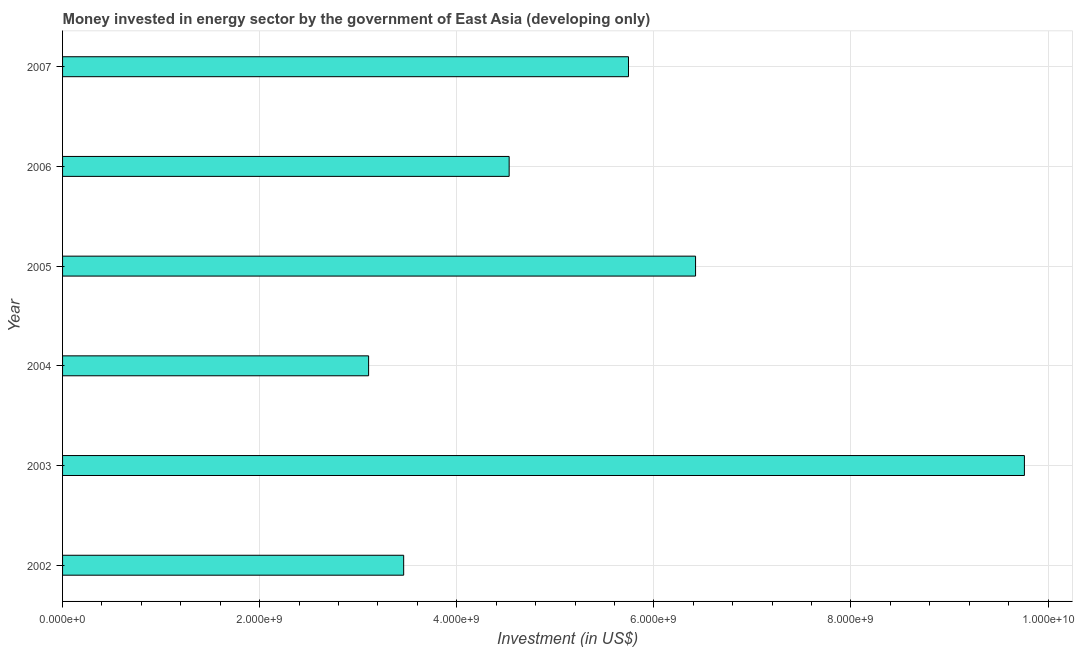Does the graph contain any zero values?
Offer a very short reply. No. Does the graph contain grids?
Give a very brief answer. Yes. What is the title of the graph?
Provide a short and direct response. Money invested in energy sector by the government of East Asia (developing only). What is the label or title of the X-axis?
Provide a succinct answer. Investment (in US$). What is the investment in energy in 2004?
Your answer should be compact. 3.11e+09. Across all years, what is the maximum investment in energy?
Make the answer very short. 9.76e+09. Across all years, what is the minimum investment in energy?
Offer a terse response. 3.11e+09. In which year was the investment in energy minimum?
Provide a short and direct response. 2004. What is the sum of the investment in energy?
Give a very brief answer. 3.30e+1. What is the difference between the investment in energy in 2006 and 2007?
Ensure brevity in your answer.  -1.21e+09. What is the average investment in energy per year?
Offer a terse response. 5.50e+09. What is the median investment in energy?
Make the answer very short. 5.14e+09. In how many years, is the investment in energy greater than 4800000000 US$?
Offer a terse response. 3. What is the ratio of the investment in energy in 2003 to that in 2007?
Provide a succinct answer. 1.7. Is the difference between the investment in energy in 2005 and 2006 greater than the difference between any two years?
Give a very brief answer. No. What is the difference between the highest and the second highest investment in energy?
Keep it short and to the point. 3.34e+09. What is the difference between the highest and the lowest investment in energy?
Your answer should be very brief. 6.65e+09. In how many years, is the investment in energy greater than the average investment in energy taken over all years?
Give a very brief answer. 3. How many bars are there?
Your answer should be very brief. 6. Are all the bars in the graph horizontal?
Make the answer very short. Yes. Are the values on the major ticks of X-axis written in scientific E-notation?
Give a very brief answer. Yes. What is the Investment (in US$) in 2002?
Provide a succinct answer. 3.46e+09. What is the Investment (in US$) of 2003?
Make the answer very short. 9.76e+09. What is the Investment (in US$) in 2004?
Your answer should be compact. 3.11e+09. What is the Investment (in US$) of 2005?
Keep it short and to the point. 6.42e+09. What is the Investment (in US$) of 2006?
Keep it short and to the point. 4.53e+09. What is the Investment (in US$) in 2007?
Provide a short and direct response. 5.74e+09. What is the difference between the Investment (in US$) in 2002 and 2003?
Make the answer very short. -6.30e+09. What is the difference between the Investment (in US$) in 2002 and 2004?
Offer a very short reply. 3.56e+08. What is the difference between the Investment (in US$) in 2002 and 2005?
Your response must be concise. -2.96e+09. What is the difference between the Investment (in US$) in 2002 and 2006?
Your answer should be very brief. -1.07e+09. What is the difference between the Investment (in US$) in 2002 and 2007?
Your answer should be very brief. -2.28e+09. What is the difference between the Investment (in US$) in 2003 and 2004?
Offer a terse response. 6.65e+09. What is the difference between the Investment (in US$) in 2003 and 2005?
Ensure brevity in your answer.  3.34e+09. What is the difference between the Investment (in US$) in 2003 and 2006?
Provide a succinct answer. 5.23e+09. What is the difference between the Investment (in US$) in 2003 and 2007?
Provide a short and direct response. 4.02e+09. What is the difference between the Investment (in US$) in 2004 and 2005?
Ensure brevity in your answer.  -3.32e+09. What is the difference between the Investment (in US$) in 2004 and 2006?
Your answer should be compact. -1.43e+09. What is the difference between the Investment (in US$) in 2004 and 2007?
Your response must be concise. -2.64e+09. What is the difference between the Investment (in US$) in 2005 and 2006?
Provide a succinct answer. 1.89e+09. What is the difference between the Investment (in US$) in 2005 and 2007?
Your response must be concise. 6.81e+08. What is the difference between the Investment (in US$) in 2006 and 2007?
Your answer should be compact. -1.21e+09. What is the ratio of the Investment (in US$) in 2002 to that in 2003?
Offer a very short reply. 0.35. What is the ratio of the Investment (in US$) in 2002 to that in 2004?
Ensure brevity in your answer.  1.11. What is the ratio of the Investment (in US$) in 2002 to that in 2005?
Keep it short and to the point. 0.54. What is the ratio of the Investment (in US$) in 2002 to that in 2006?
Keep it short and to the point. 0.76. What is the ratio of the Investment (in US$) in 2002 to that in 2007?
Make the answer very short. 0.6. What is the ratio of the Investment (in US$) in 2003 to that in 2004?
Offer a very short reply. 3.14. What is the ratio of the Investment (in US$) in 2003 to that in 2005?
Make the answer very short. 1.52. What is the ratio of the Investment (in US$) in 2003 to that in 2006?
Your answer should be very brief. 2.15. What is the ratio of the Investment (in US$) in 2004 to that in 2005?
Your answer should be compact. 0.48. What is the ratio of the Investment (in US$) in 2004 to that in 2006?
Ensure brevity in your answer.  0.69. What is the ratio of the Investment (in US$) in 2004 to that in 2007?
Offer a very short reply. 0.54. What is the ratio of the Investment (in US$) in 2005 to that in 2006?
Make the answer very short. 1.42. What is the ratio of the Investment (in US$) in 2005 to that in 2007?
Provide a short and direct response. 1.12. What is the ratio of the Investment (in US$) in 2006 to that in 2007?
Provide a short and direct response. 0.79. 